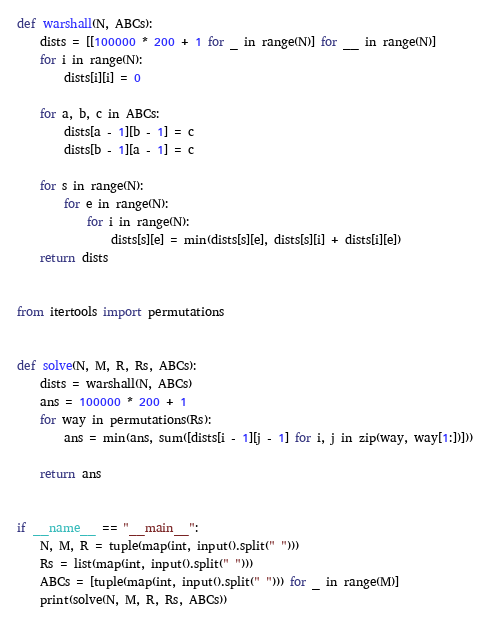Convert code to text. <code><loc_0><loc_0><loc_500><loc_500><_Python_>def warshall(N, ABCs):
    dists = [[100000 * 200 + 1 for _ in range(N)] for __ in range(N)]
    for i in range(N):
        dists[i][i] = 0

    for a, b, c in ABCs:
        dists[a - 1][b - 1] = c
        dists[b - 1][a - 1] = c

    for s in range(N):
        for e in range(N):
            for i in range(N):
                dists[s][e] = min(dists[s][e], dists[s][i] + dists[i][e])
    return dists


from itertools import permutations


def solve(N, M, R, Rs, ABCs):
    dists = warshall(N, ABCs)
    ans = 100000 * 200 + 1 
    for way in permutations(Rs):
        ans = min(ans, sum([dists[i - 1][j - 1] for i, j in zip(way, way[1:])]))

    return ans


if __name__ == "__main__":
    N, M, R = tuple(map(int, input().split(" ")))
    Rs = list(map(int, input().split(" ")))
    ABCs = [tuple(map(int, input().split(" "))) for _ in range(M)]
    print(solve(N, M, R, Rs, ABCs))
</code> 